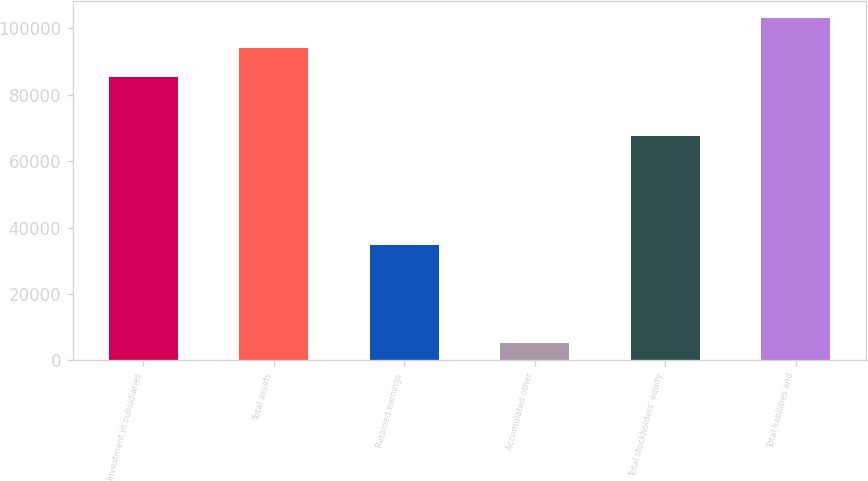Convert chart. <chart><loc_0><loc_0><loc_500><loc_500><bar_chart><fcel>Investment in subsidiaries<fcel>Total assets<fcel>Retained earnings<fcel>Accumulated other<fcel>Total stockholders' equity<fcel>Total liabilities and<nl><fcel>85429<fcel>94203.2<fcel>34683<fcel>5366<fcel>67531<fcel>102977<nl></chart> 